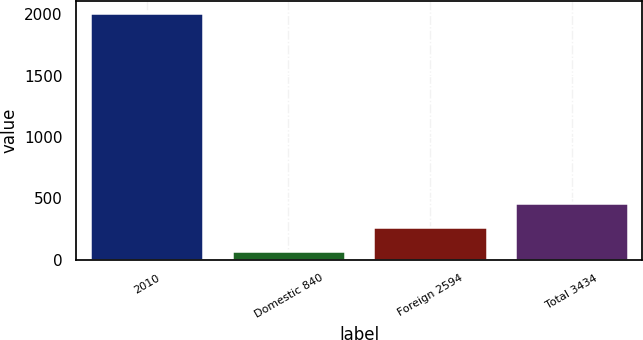Convert chart to OTSL. <chart><loc_0><loc_0><loc_500><loc_500><bar_chart><fcel>2010<fcel>Domestic 840<fcel>Foreign 2594<fcel>Total 3434<nl><fcel>2008<fcel>73.1<fcel>266.59<fcel>460.08<nl></chart> 